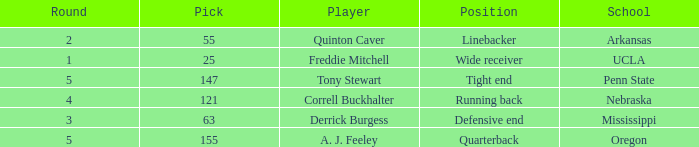Who was the player who was pick number 147? Tony Stewart. 